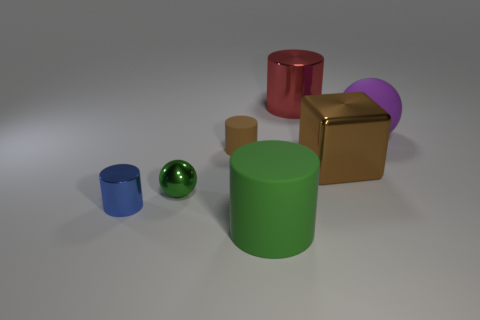Add 3 brown matte objects. How many objects exist? 10 Subtract all cubes. How many objects are left? 6 Subtract all brown matte cylinders. Subtract all large purple matte objects. How many objects are left? 5 Add 7 green balls. How many green balls are left? 8 Add 1 brown things. How many brown things exist? 3 Subtract 0 yellow blocks. How many objects are left? 7 